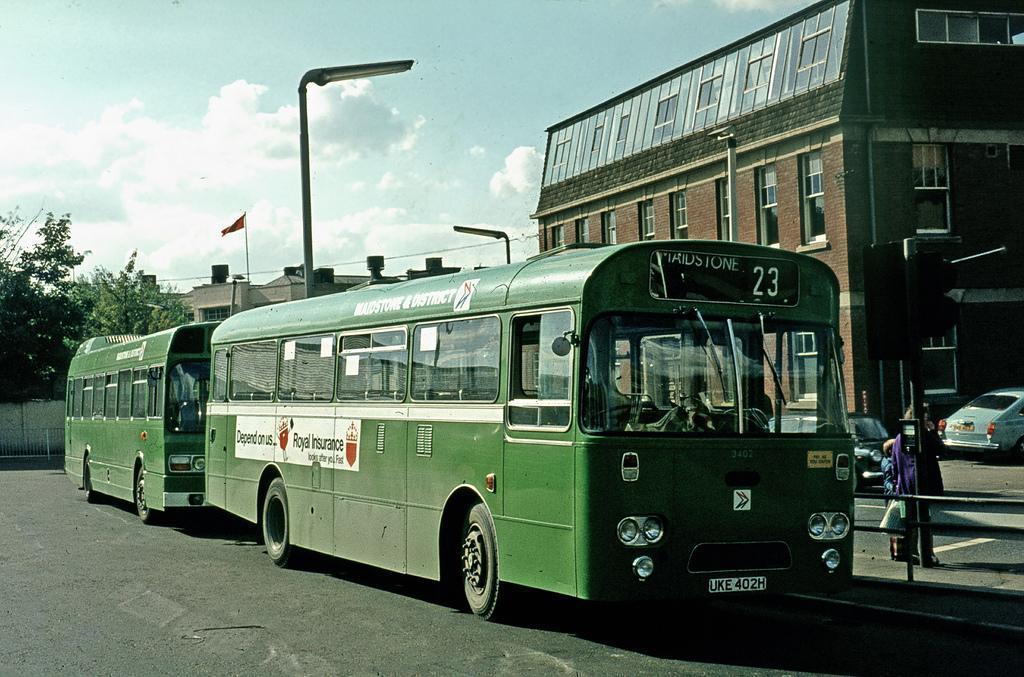How many buses are there?
Give a very brief answer. 2. How many buses are shown?
Give a very brief answer. 2. How many flags are waving?
Give a very brief answer. 1. How many people are on the sidewalk?
Give a very brief answer. 2. How many tires are seen?
Give a very brief answer. 4. How many buses?
Give a very brief answer. 2. How many white cars?
Give a very brief answer. 1. How many flags?
Give a very brief answer. 1. 